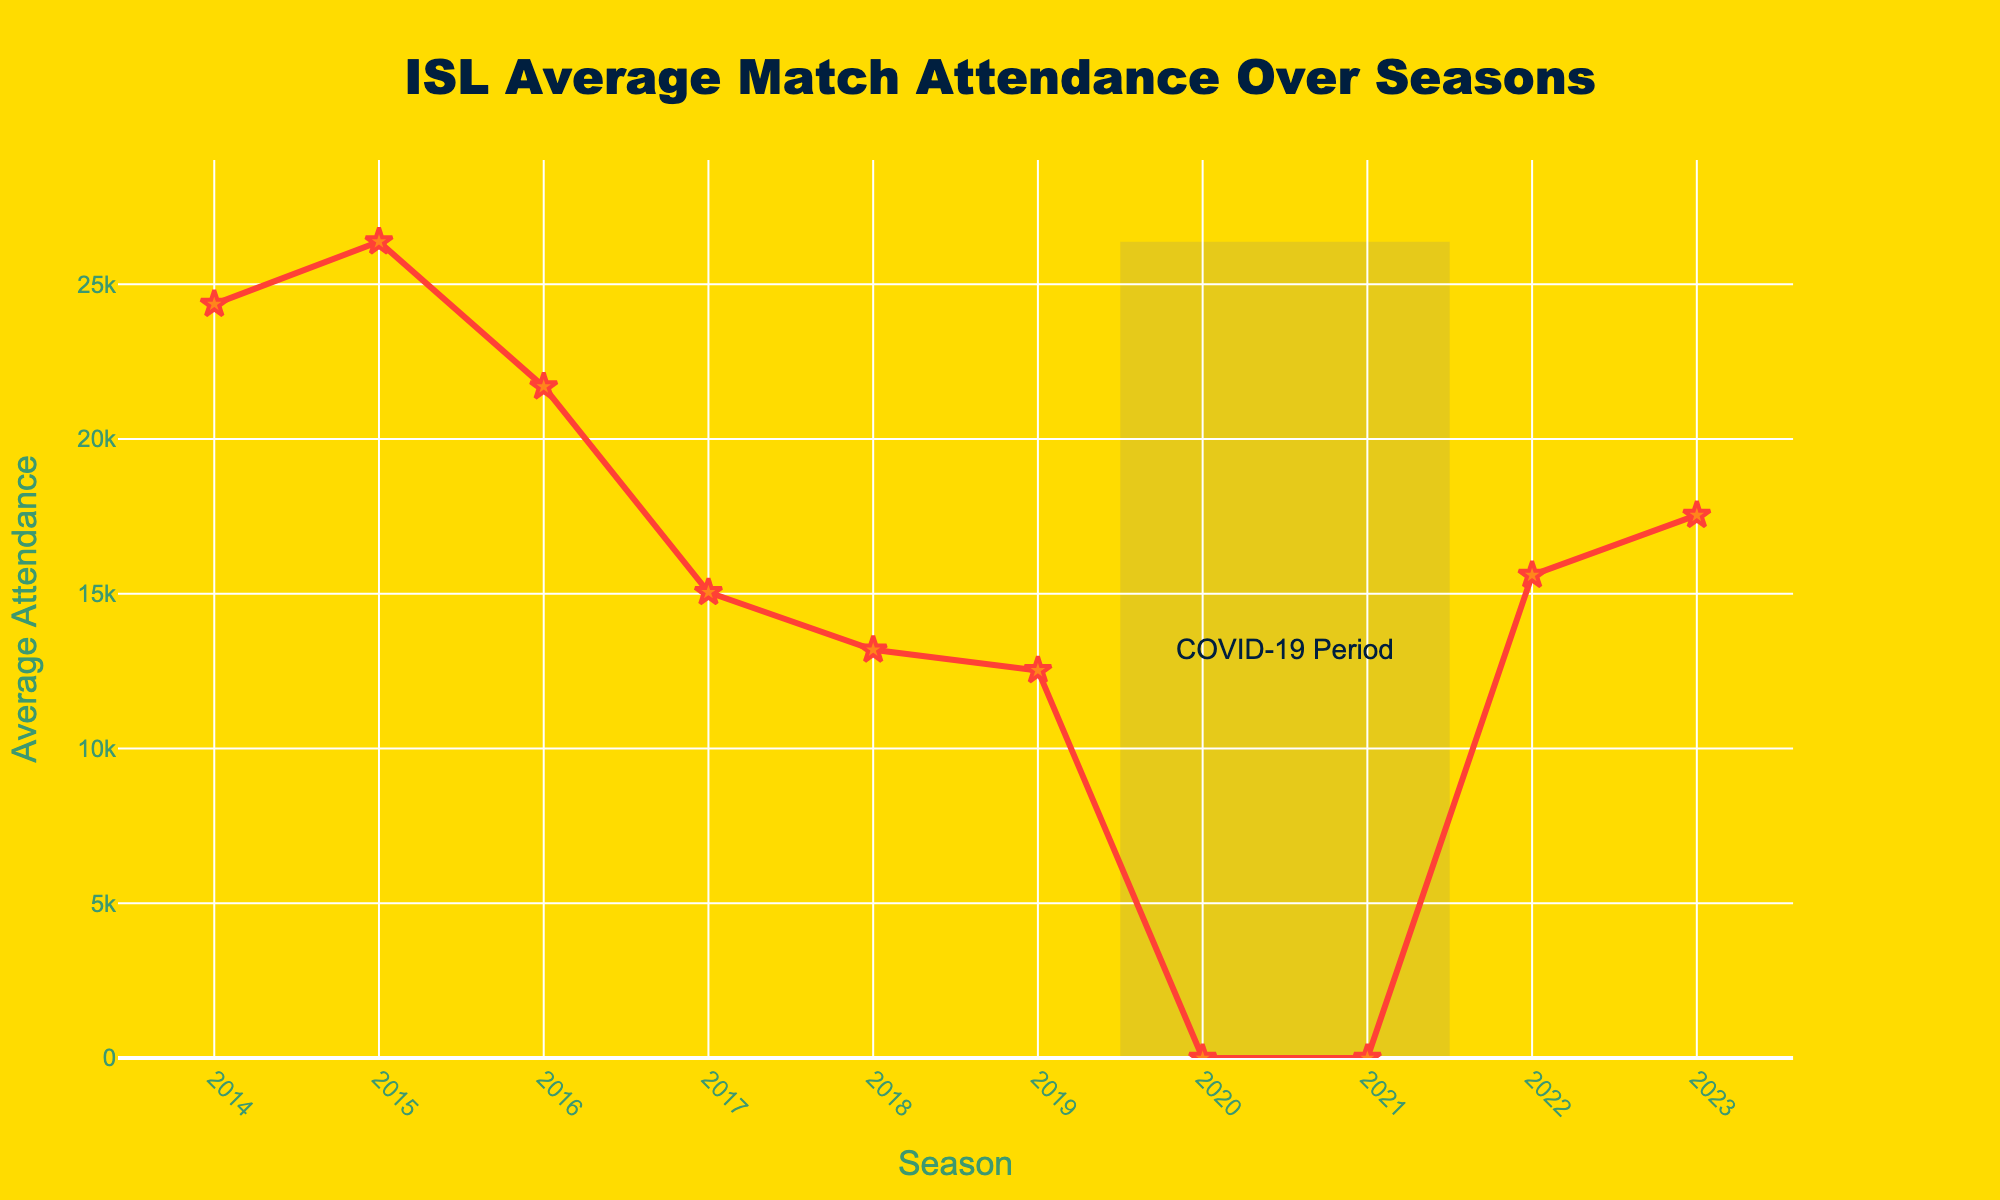What's the maximum average attendance recorded in ISL matches over the seasons? The highest point on the line chart represents the maximum average attendance. Looking at the chart, the peak is at the year 2015 with an attendance of 26376.
Answer: 26376 What's the minimum average attendance recorded in ISL matches, excluding the seasons affected by COVID-19? Excluding the seasons 2020 and 2021 (marked by the grey rectangle for the COVID-19 period with attendance of 0), the lowest point is in 2019 with an average attendance of 12522.
Answer: 12522 How much did the average attendance change from 2016 to 2017? Find the value for 2016 (21690) and 2017 (15047). Subtract the 2017 value from the 2016 value: 21690 - 15047 = 6643.
Answer: 6643 What is the average attendance for the period before the COVID-19 pandemic (2014-2019)? Sum the attendance values from 2014 to 2019 (24357+26376+21690+15047+13188+12522) and divide by the number of seasons (6). Calculation: (24357+26376+21690+15047+13188+12522) / 6 = 18896.67.
Answer: 18896.67 By how much did the average attendance increase from 2022 to 2023? Find the average attendance for 2022 (15601) and 2023 (17538). Subtract the 2022 value from the 2023 value: 17538 - 15601 = 1937.
Answer: 1937 Comparing the average attendance between 2014 and 2023, which season had a higher value and by how much? Find the average attendance for 2014 (24357) and 2023 (17538). Subtract the 2023 value from the 2014 value: 24357 - 17538. This difference is 6819, and 2014 had a higher attendance.
Answer: 2014 by 6819 What is the difference in average attendance between the season with the highest value and the season immediately following the COVID-19 pandemic? The season with the highest value is 2015 (26376). The season immediately following COVID-19 is 2022 (15601). Subtract the 2022 value from the 2015 value: 26376 - 15601 = 10775.
Answer: 10775 What trend can be observed in the average attendance from 2014 to 2016? Looking at the chart, the average attendance increases from 2014 (24357) to 2015 (26376), then decreases in 2016 (21690). The trend is an initial increase followed by a decrease.
Answer: Increase then decrease What visual cues indicate that the COVID-19 pandemic affected the average attendance? The seasons 2020 and 2021 are marked with a grey rectangle labeled "COVID-19 Period," and the average attendance for these seasons is shown as 0, indicating no attendance.
Answer: Grey rectangle, 0 attendance 